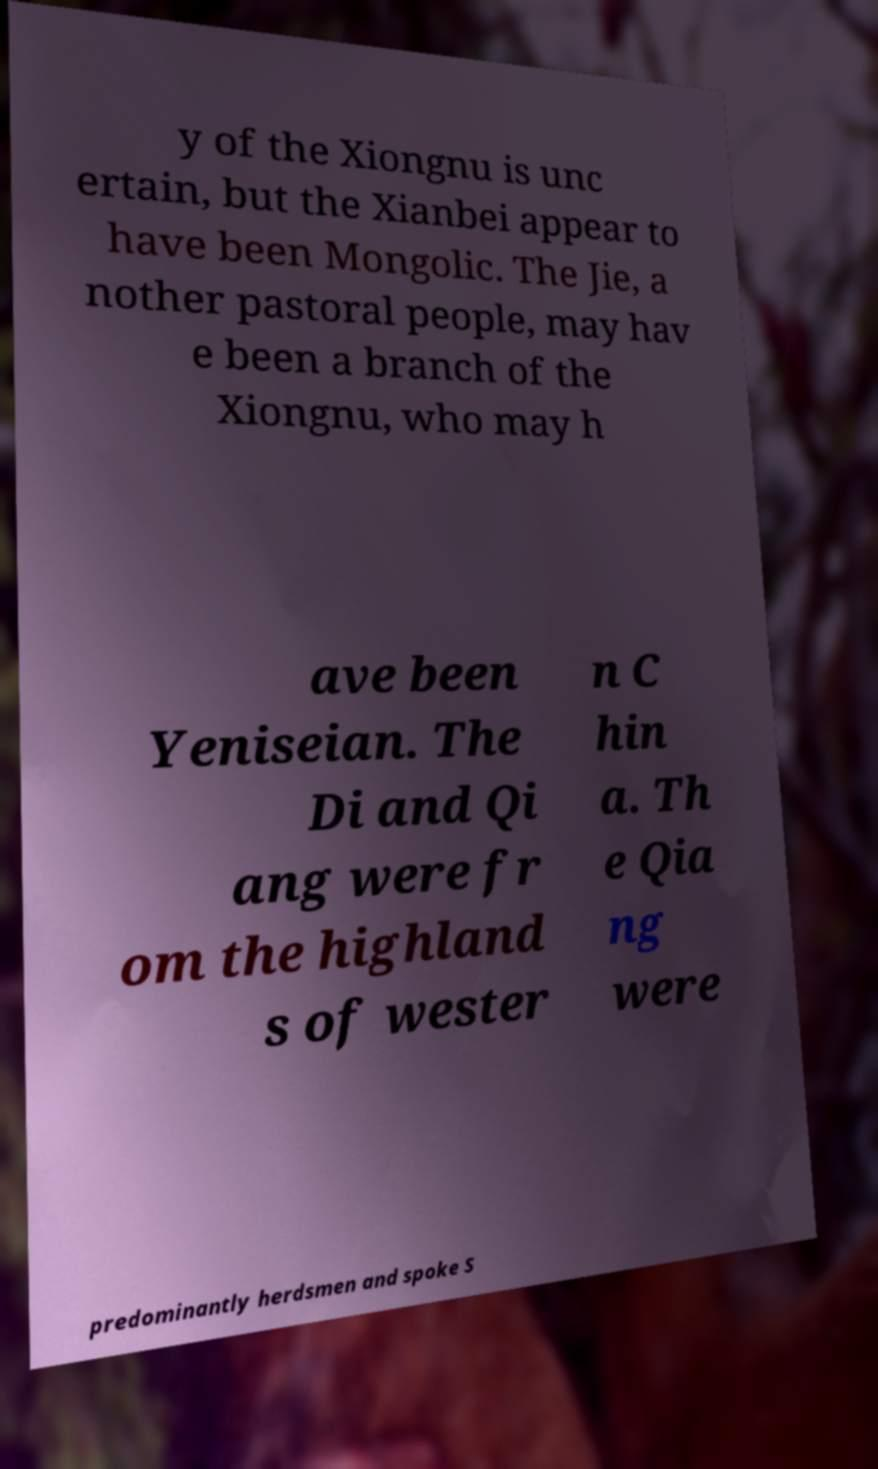What messages or text are displayed in this image? I need them in a readable, typed format. y of the Xiongnu is unc ertain, but the Xianbei appear to have been Mongolic. The Jie, a nother pastoral people, may hav e been a branch of the Xiongnu, who may h ave been Yeniseian. The Di and Qi ang were fr om the highland s of wester n C hin a. Th e Qia ng were predominantly herdsmen and spoke S 